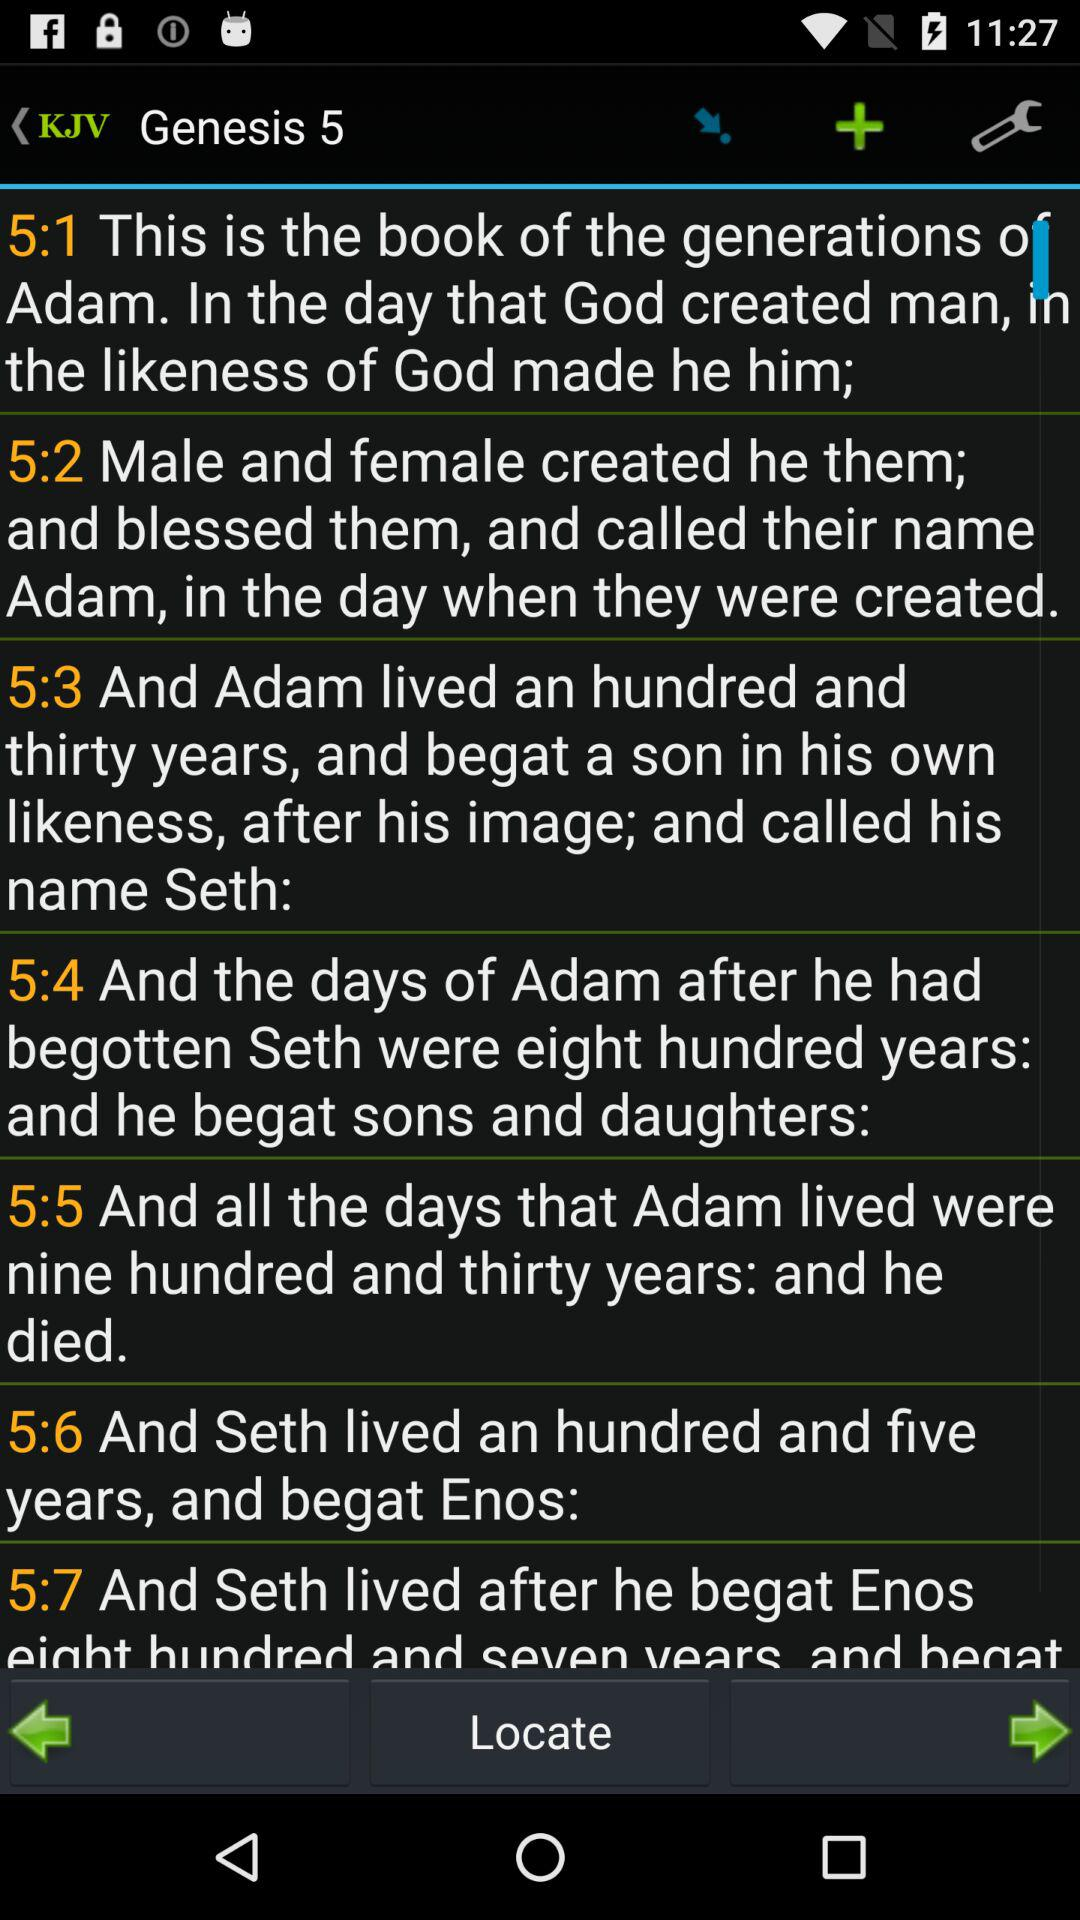What is the name of Adam's son? The name is Seth. 